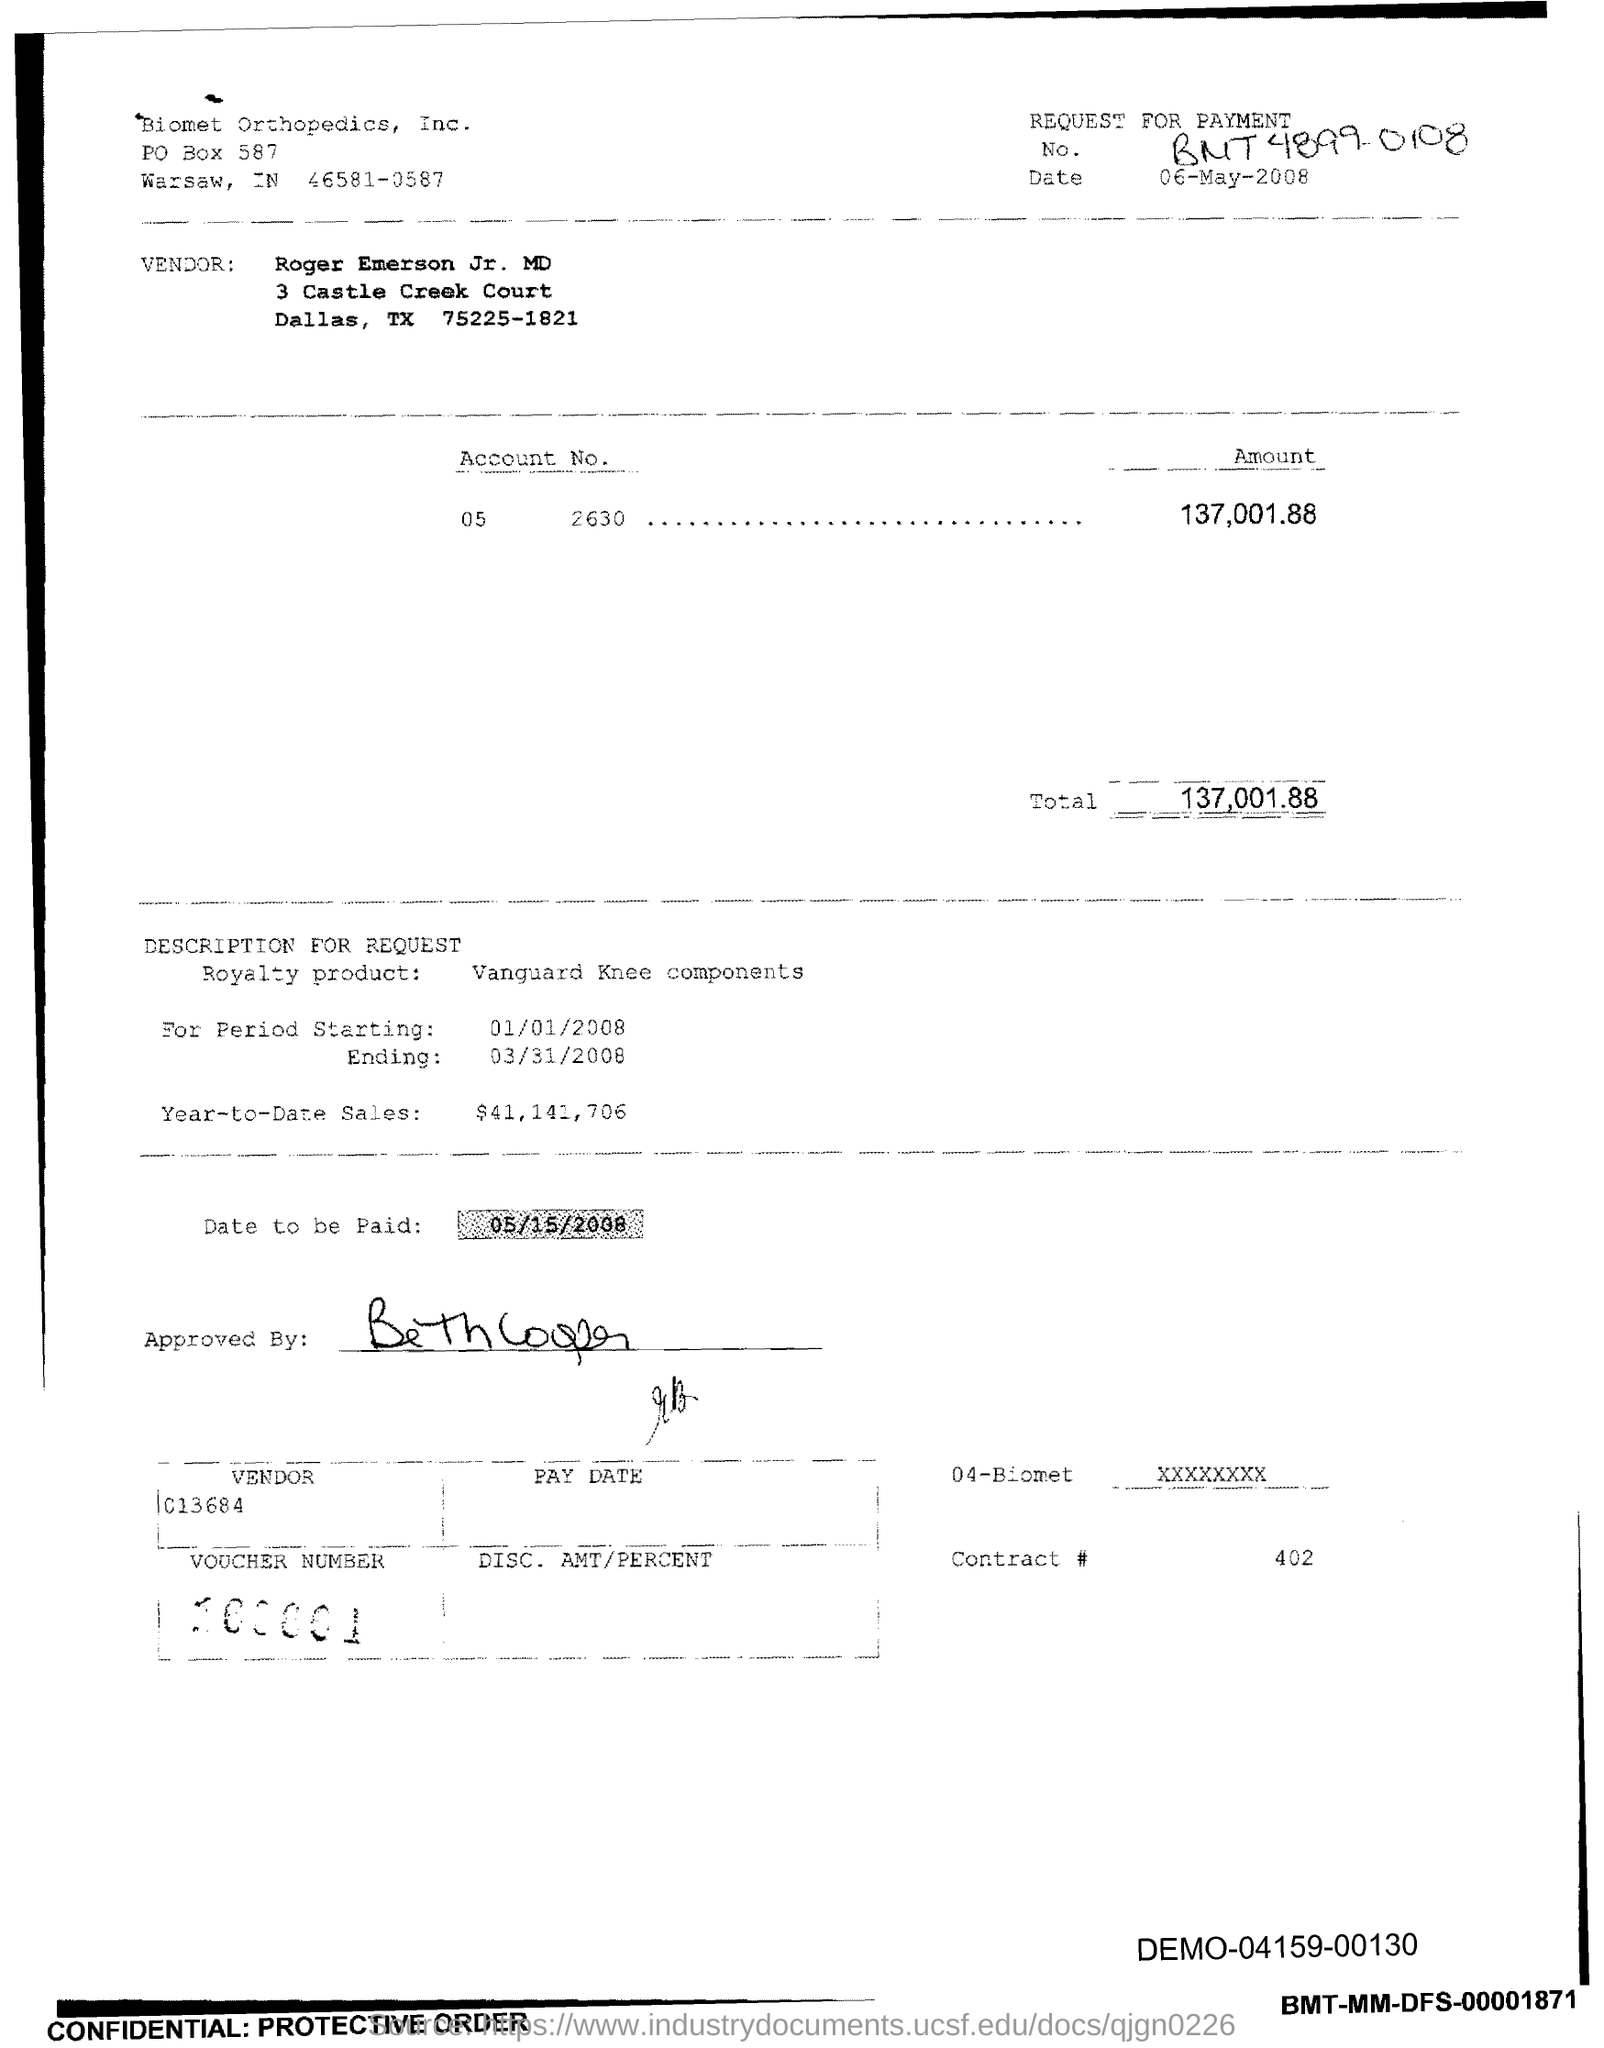What is the PO Box Number mentioned in the document?
Provide a short and direct response. 587. What is the Total?
Offer a terse response. 137,001.88. What is the Contract # Number?
Your response must be concise. 402. 